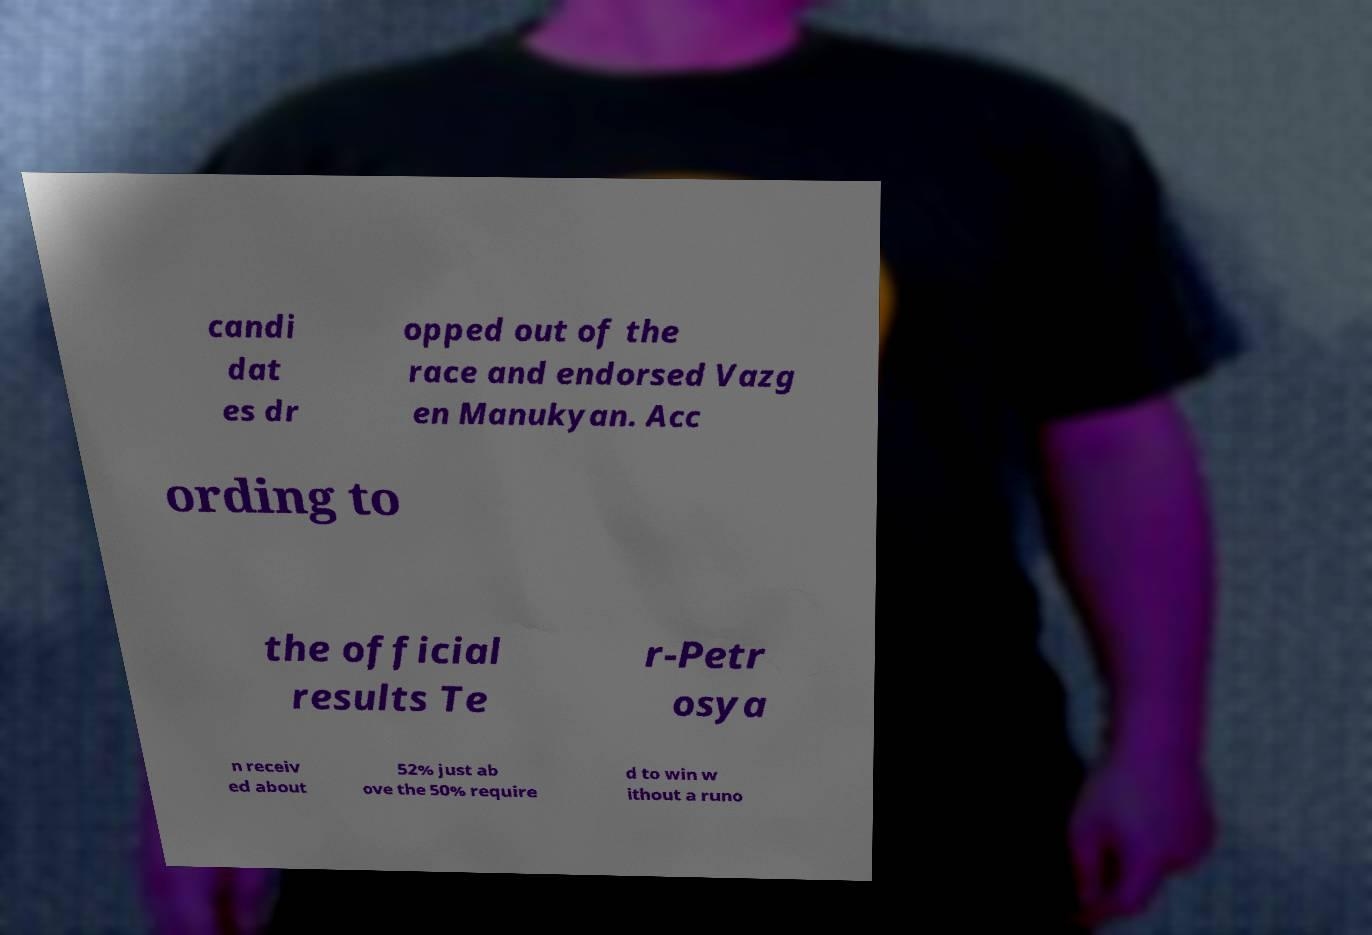Can you accurately transcribe the text from the provided image for me? candi dat es dr opped out of the race and endorsed Vazg en Manukyan. Acc ording to the official results Te r-Petr osya n receiv ed about 52% just ab ove the 50% require d to win w ithout a runo 